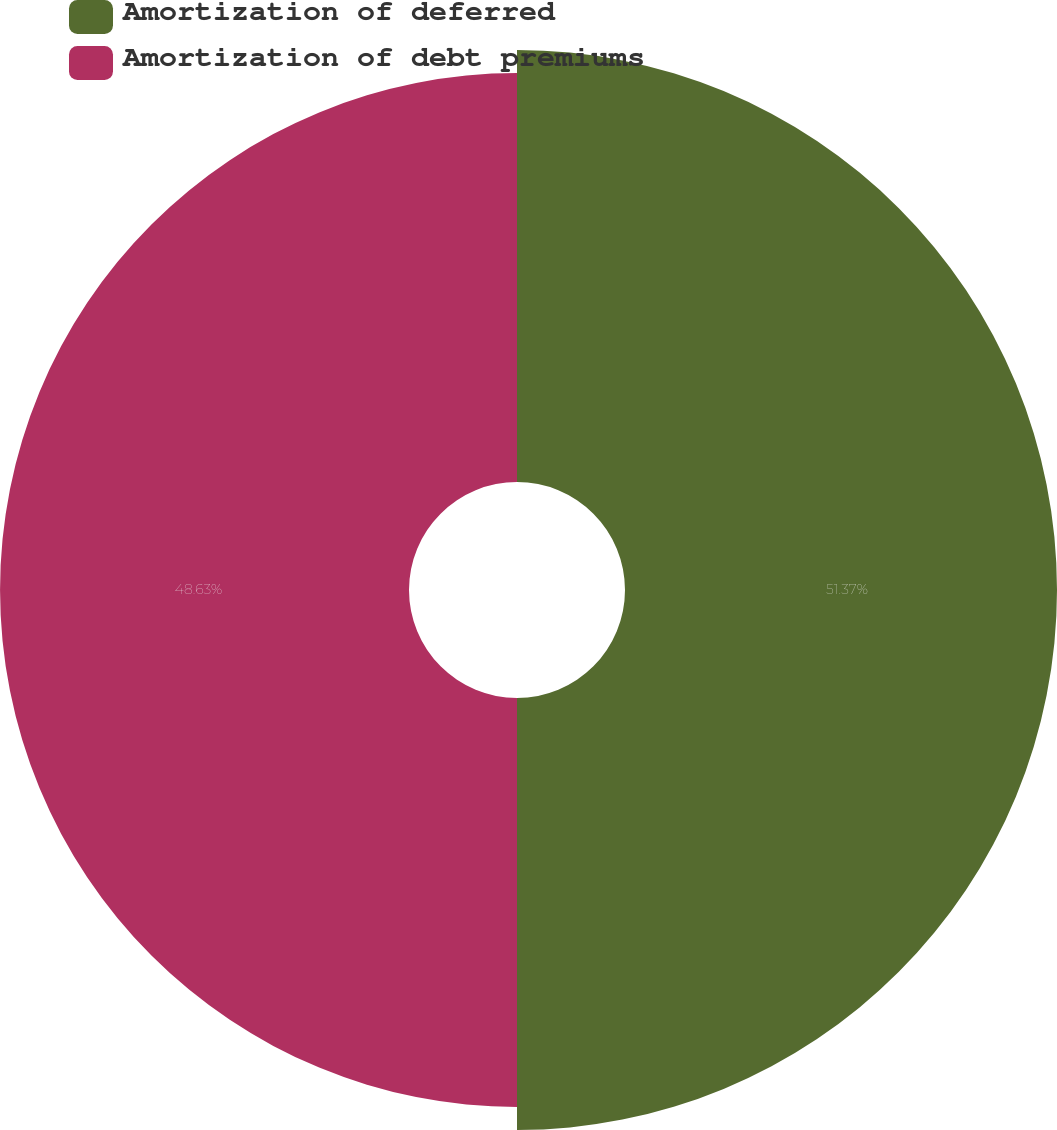Convert chart. <chart><loc_0><loc_0><loc_500><loc_500><pie_chart><fcel>Amortization of deferred<fcel>Amortization of debt premiums<nl><fcel>51.37%<fcel>48.63%<nl></chart> 